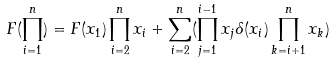Convert formula to latex. <formula><loc_0><loc_0><loc_500><loc_500>F ( \prod _ { i = 1 } ^ { n } ) = F ( x _ { 1 } ) \prod _ { i = 2 } ^ { n } x _ { i } + \sum _ { i = 2 } ^ { n } ( \prod _ { j = 1 } ^ { i - 1 } x _ { j } \delta ( x _ { i } ) \prod _ { k = i + 1 } ^ { n } x _ { k } )</formula> 